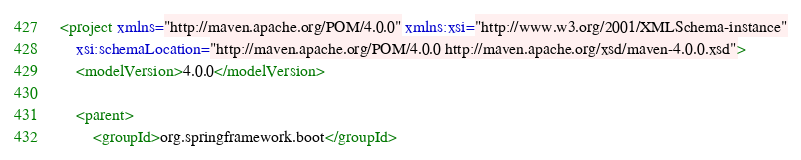<code> <loc_0><loc_0><loc_500><loc_500><_XML_><project xmlns="http://maven.apache.org/POM/4.0.0" xmlns:xsi="http://www.w3.org/2001/XMLSchema-instance"
	xsi:schemaLocation="http://maven.apache.org/POM/4.0.0 http://maven.apache.org/xsd/maven-4.0.0.xsd">
	<modelVersion>4.0.0</modelVersion>

	<parent>
		<groupId>org.springframework.boot</groupId></code> 